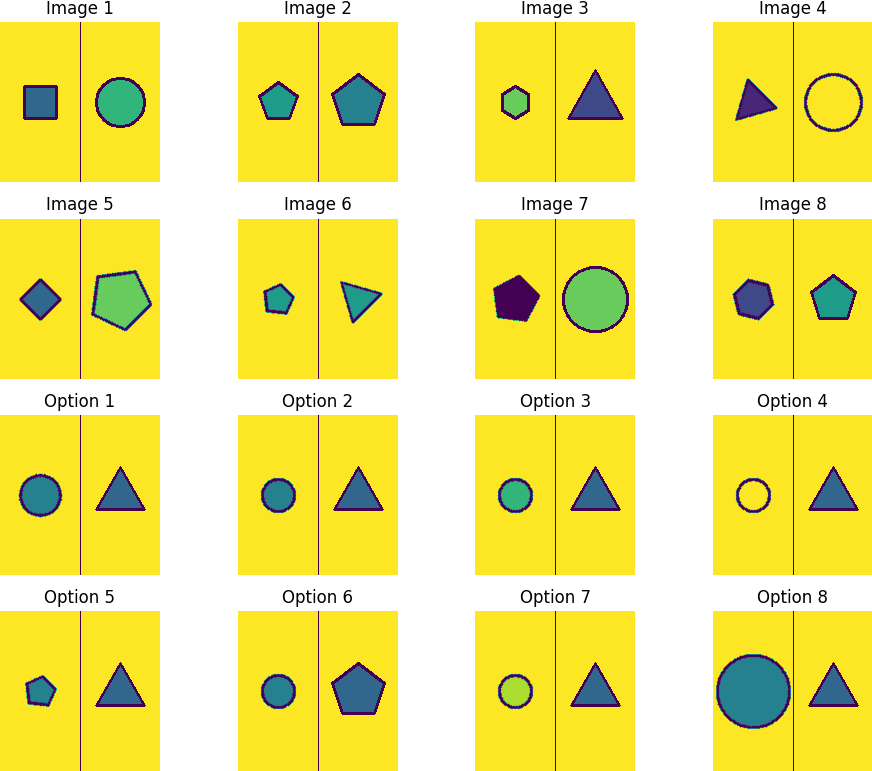Each image has 8 images labeled as Image 1 to Image 8. These 8 images follow a specific pattern. Detect the pattern and select the next image in the sequence from the 8 available options. To determine the next image in the sequence, one must first identify the pattern within the given images. Observing the sequence, we can note the following recurring elements:

1. Shape rotation: Square (4 sides), Circle (infinite sides), Pentagon (5 sides), Triangle (3 sides), and so forth.
2. Color alternation: The sequence of colors is blue, green, purple, with each color appearing on shapes with an increasing number of sides.
3. Border color: Each shape's border color alternates between light blue, red, dark blue, and green.

The pattern appears to be a progression based on the number of sides of the shapes, with a repeating order of colors for both the shapes and their borders. Based on this pattern, after the purple circle (infinite sides) with a green border (Image 7), comes the blue pentagon (5 sides) with a light blue border (Image 8). Therefore, the next shape should logically be a green shape with red border. Since the pattern of sides is 4 (square), infinite (circle), 5 (pentagon), 3 (triangle), the next shape should have 4 sides.

The next image should be a green square with a red border, which is Option 2. 